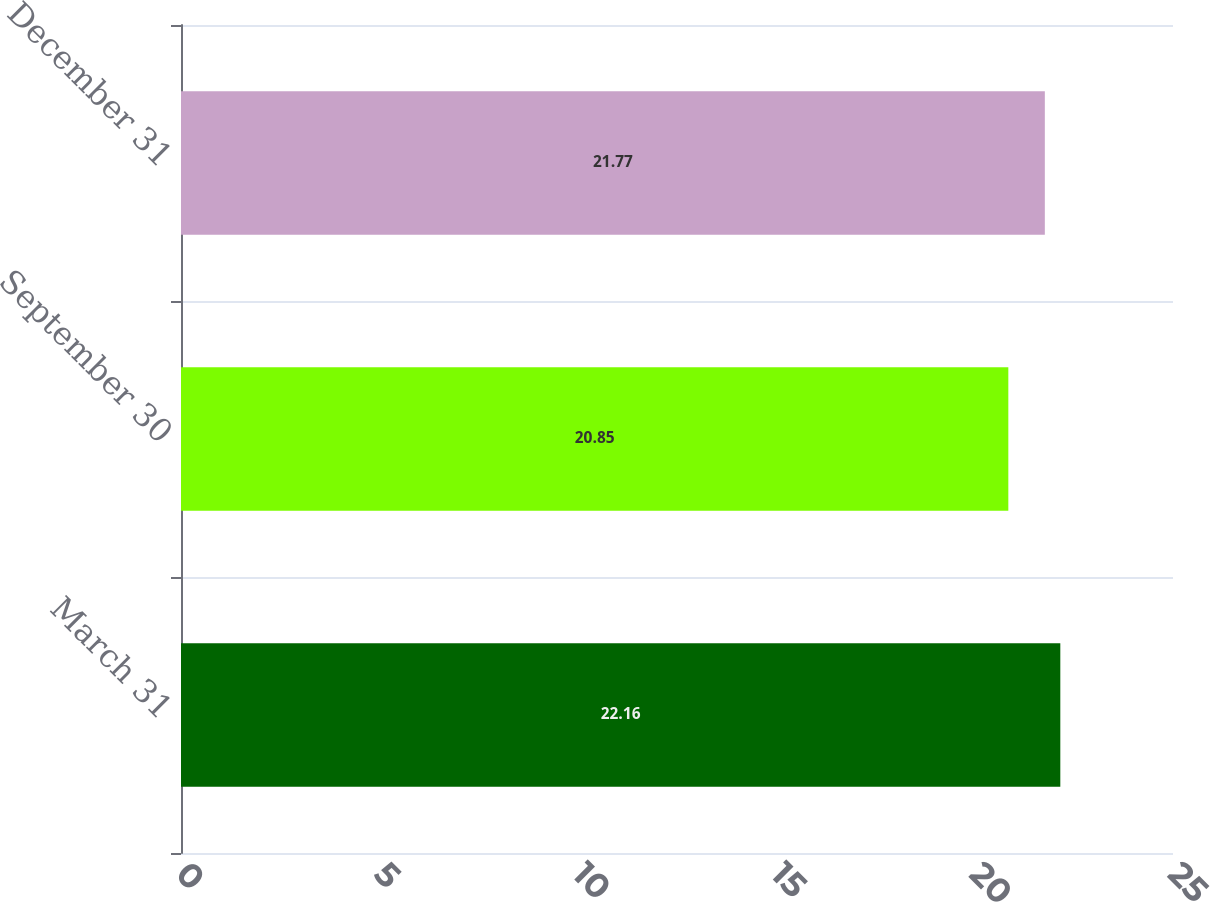Convert chart. <chart><loc_0><loc_0><loc_500><loc_500><bar_chart><fcel>March 31<fcel>September 30<fcel>December 31<nl><fcel>22.16<fcel>20.85<fcel>21.77<nl></chart> 